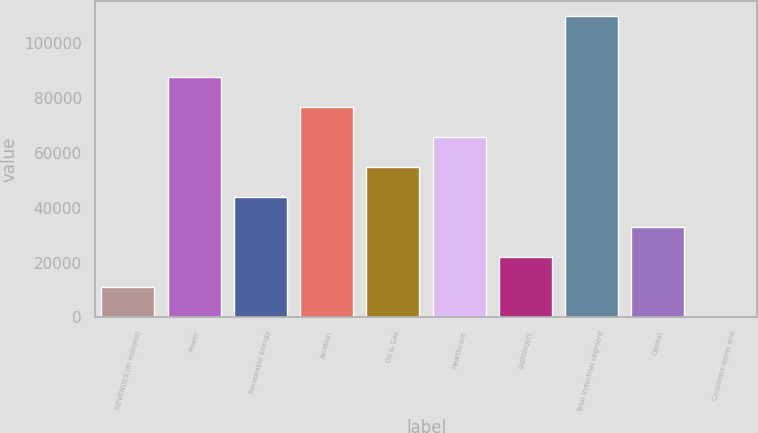Convert chart. <chart><loc_0><loc_0><loc_500><loc_500><bar_chart><fcel>REVENUES (In millions)<fcel>Power<fcel>Renewable Energy<fcel>Aviation<fcel>Oil & Gas<fcel>Healthcare<fcel>Lighting(c)<fcel>Total industrial segment<fcel>Capital<fcel>Corporate items and<nl><fcel>10990.2<fcel>87886.6<fcel>43945.8<fcel>76901.4<fcel>54931<fcel>65916.2<fcel>21975.4<fcel>109857<fcel>32960.6<fcel>5<nl></chart> 